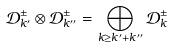Convert formula to latex. <formula><loc_0><loc_0><loc_500><loc_500>\mathcal { D } ^ { \pm } _ { k ^ { \prime } } \otimes \mathcal { D } ^ { \pm } _ { k ^ { \prime \prime } } = \bigoplus _ { k \geq k ^ { \prime } + k ^ { \prime \prime } } \mathcal { D } ^ { \pm } _ { k }</formula> 